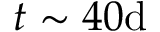Convert formula to latex. <formula><loc_0><loc_0><loc_500><loc_500>t \sim 4 0 d</formula> 